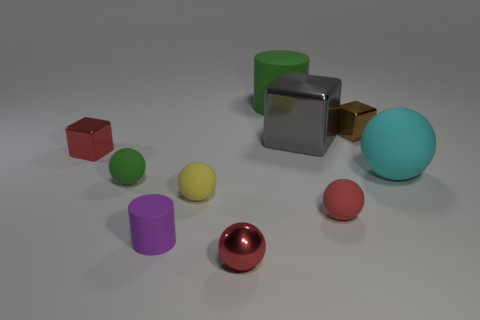Subtract all small shiny balls. How many balls are left? 4 Subtract all green balls. How many balls are left? 4 Subtract 1 blocks. How many blocks are left? 2 Subtract all brown cylinders. How many red balls are left? 2 Subtract all small green shiny cubes. Subtract all shiny things. How many objects are left? 6 Add 6 red things. How many red things are left? 9 Add 8 red metal things. How many red metal things exist? 10 Subtract 0 purple balls. How many objects are left? 10 Subtract all cylinders. How many objects are left? 8 Subtract all yellow balls. Subtract all cyan blocks. How many balls are left? 4 